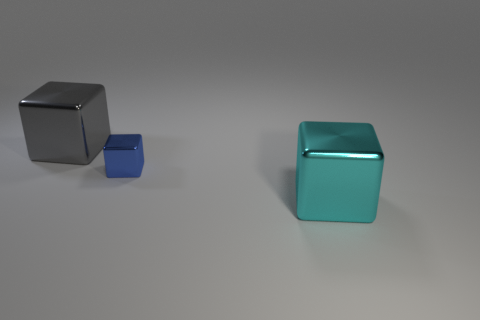Add 3 cyan metallic things. How many objects exist? 6 Subtract all red shiny cylinders. Subtract all big cyan blocks. How many objects are left? 2 Add 1 big metal cubes. How many big metal cubes are left? 3 Add 3 big cyan metallic spheres. How many big cyan metallic spheres exist? 3 Subtract 0 yellow cylinders. How many objects are left? 3 